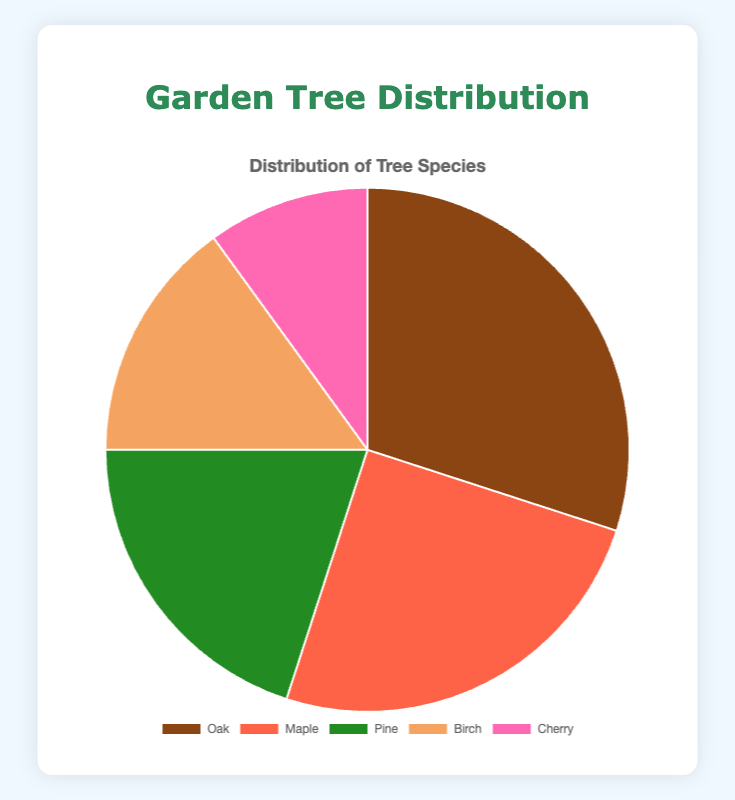What's the total percentage of all trees in the garden? Add the percentages of all tree species: Oak (30%), Maple (25%), Pine (20%), Birch (15%), and Cherry (10%). The total is 30 + 25 + 20 + 15 + 10 = 100%
Answer: 100% Which tree species has the highest percentage in the garden? Look at the percentage data provided and identify the species with the highest value. Oak has the highest percentage at 30%.
Answer: Oak How much more percentage do Oak trees have compared to Cherry trees? Calculate the difference between the percentages of Oak and Cherry trees: 30% (Oak) - 10% (Cherry) = 20%
Answer: 20% If you combine the percentage of Pine and Birch trees, does it exceed the percentage of Maple trees? Add the percentages of Pine (20%) and Birch (15%): 20% + 15% = 35%. Compare this with the percentage of Maple (25%). 35% is greater than 25%
Answer: Yes Which tree species has the smallest representation in the garden? Identify the species with the smallest percentage value. Cherry has the smallest representation at 10%
Answer: Cherry What's the average percentage of the Oak and Maple trees? Add the percentages of Oak (30%) and Maple (25%) and divide by 2: (30 + 25) / 2 = 27.5%
Answer: 27.5% How do the combined percentages of Birch and Cherry trees compare to Pine trees? Sum the percentages of Birch (15%) and Cherry (10%): 15% + 10% = 25%. Compare this with Pine's percentage (20%). 25% is greater than 20%
Answer: Greater What percentage of the garden is comprised of non-Oak trees? Subtract the percentage of Oak trees (30%) from the total (100%): 100% - 30% = 70%
Answer: 70% In terms of visual representation, what color represents the Maple trees? Observe the color legend in the chart for the species Maple. Maple is represented by the color associated with 25% slice, which is often labeled.
Answer: Red What is the difference in percentage between Pine and Birch trees? Subtract the percentage of Birch trees (15%) from Pine trees (20%): 20% - 15% = 5%
Answer: 5% 